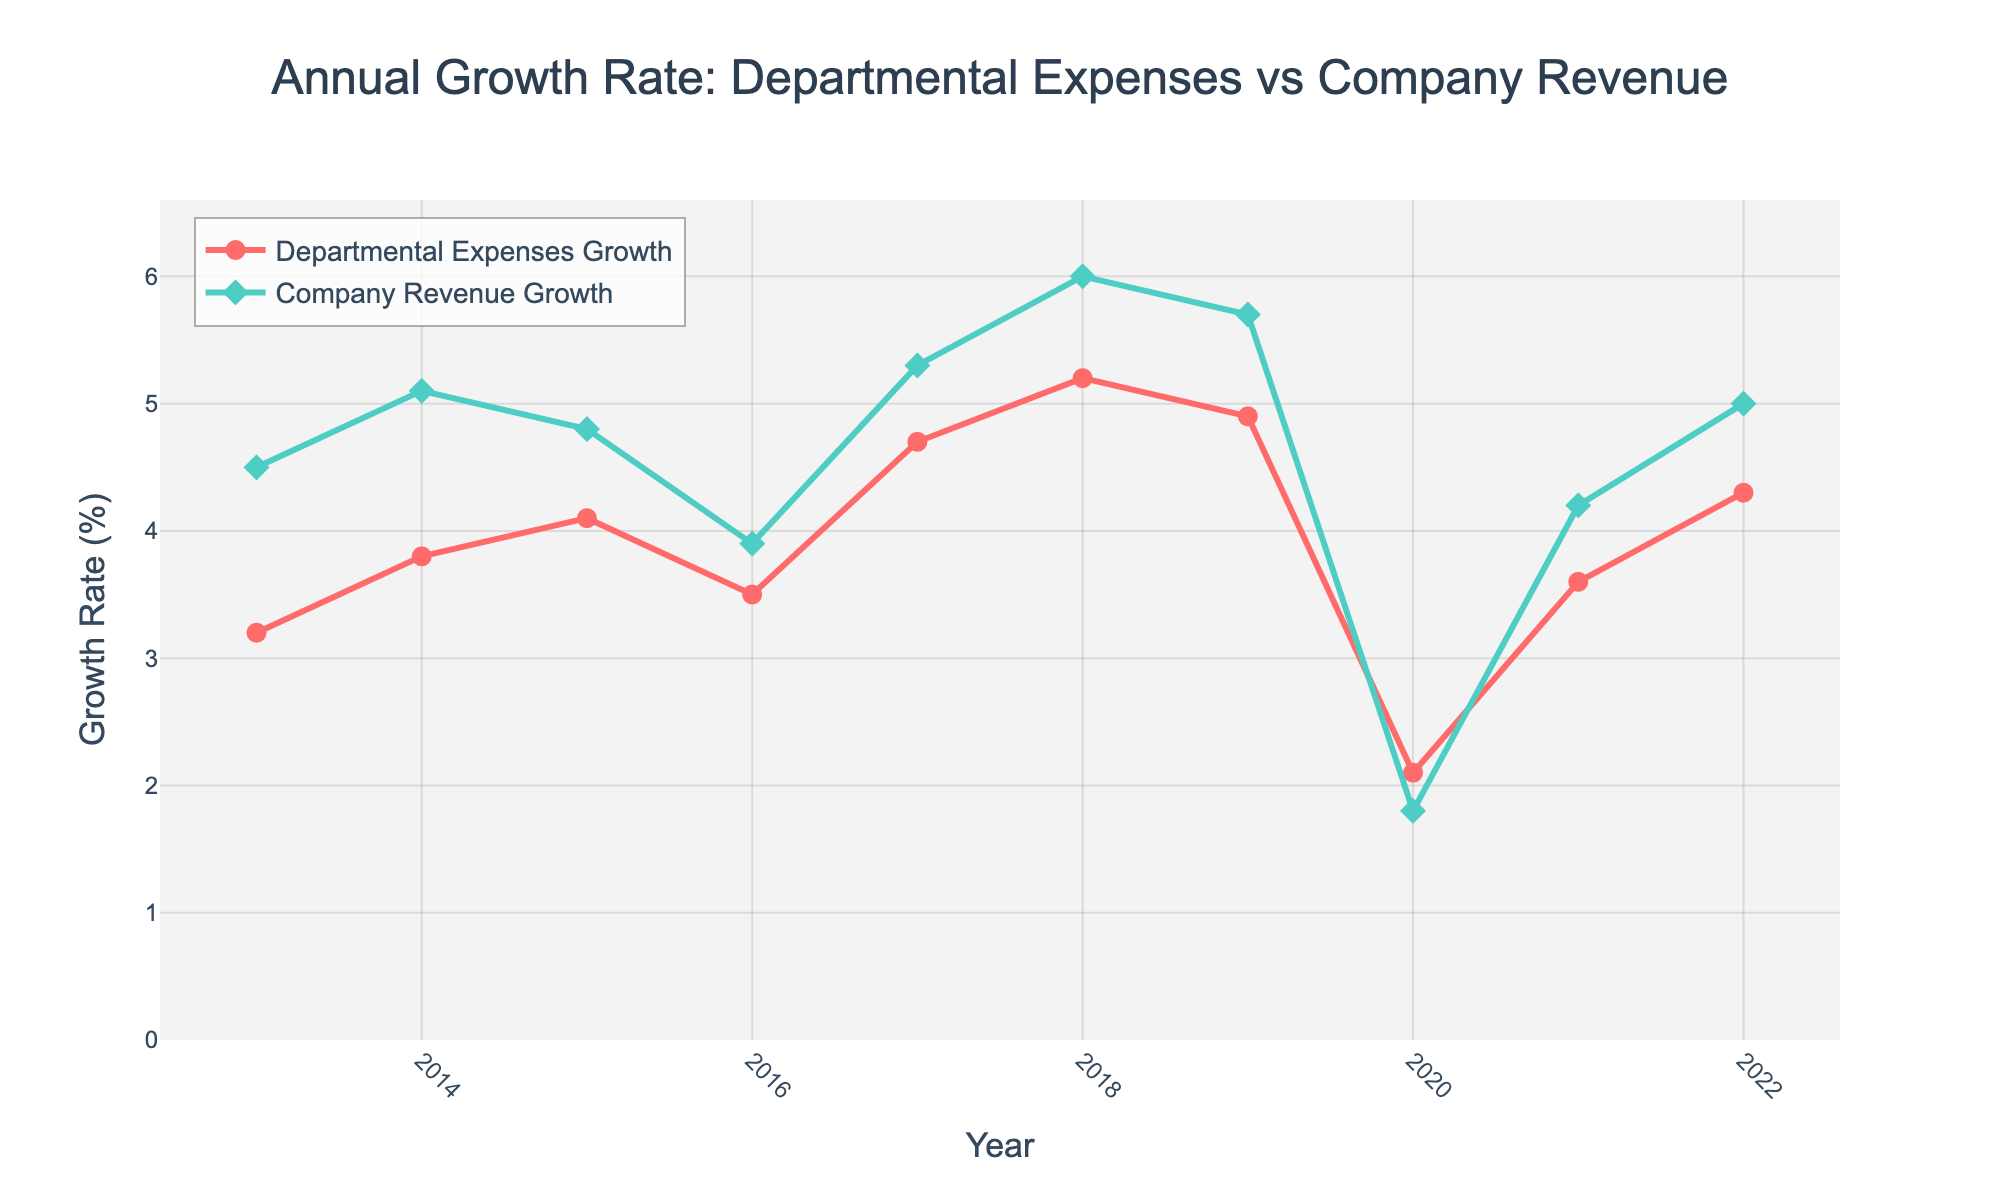What's the average growth rate of departmental expenses for the entire period? To find the average, sum up all the annual growth rates of departmental expenses (3.2 + 3.8 + 4.1 + 3.5 + 4.7 + 5.2 + 4.9 + 2.1 + 3.6 + 4.3) and then divide by the number of years (10). Thus, the average is (3.2 + 3.8 + 4.1 + 3.5 + 4.7 + 5.2 + 4.9 + 2.1 + 3.6 + 4.3)/10 = 39.4/10 = 3.94.
Answer: 3.94% Which year saw the lowest growth rate in departmental expenses? By visually inspecting the lowest point on the red line representing departmental expenses growth, the year 2020 shows the lowest growth rate at 2.1%.
Answer: 2020 Which year had the highest growth rate difference between departmental expenses and company revenue? Calculate the difference for each year and find the year with the maximum difference: 2013: 4.5 - 3.2 = 1.3, 2014: 5.1 - 3.8 = 1.3, 2015: 4.8 - 4.1 = 0.7, 2016: 3.9 - 3.5 = 0.4, 2017: 5.3 - 4.7 = 0.6, 2018: 6.0 - 5.2 = 0.8, 2019: 5.7 - 4.9 = 0.8, 2020: 1.8 - 2.1 = -0.3, 2021: 4.2 - 3.6 = 0.6, 2022: 5.0 - 4.3 = 0.7. The maximum difference is in 2013 and 2014 with a value of 1.3.
Answer: 2013, 2014 In which year did both departmental expenses and company revenue growth decrease compared to the previous year? Compare each year's growth rate with the previous year for both series and find the year where both series show a decrease. From 2019 to 2020, departmental expenses growth decreased from 4.9% to 2.1%, and company revenue growth decreased from 5.7% to 1.8%.
Answer: 2020 What is the highest growth rate for company revenue during the given period? By visually inspecting the topmost point on the green line representing company revenue growth, the highest point is in 2018 at 6.0%.
Answer: 6.0% What is the trend for departmental expenses growth from 2013 to 2022? By observing the red line representing departmental expenses growth, we can see variability with an overall pattern of fluctuations, but a generally increasing trend punctuated by a significant dip in 2020.
Answer: Generally increasing with fluctuations How does the growth of company revenue in 2020 compare to the previous seven years? Visually compare the green line's 2020 data point (1.8%) with the previous seven data points (2013–2019). Each of these years has higher company revenue growth than 2020 (ranging from 3.9% to 6.0%).
Answer: Lower If departmental expenses growth is projected to continue its trend from 2019 to 2022 for the next year, what would be the expected growth rate for 2023? Identify the trend from 2019 (4.9%), 2020 (2.1%), 2021 (3.6%), and 2022 (4.3%). The values are increasing after the dip in 2020, with growth approximately increasing by 0.7 each year post-2020. Thus, the estimated growth for 2023 would be around 4.3 + 0.7 = 5.0%.
Answer: 5.0% 